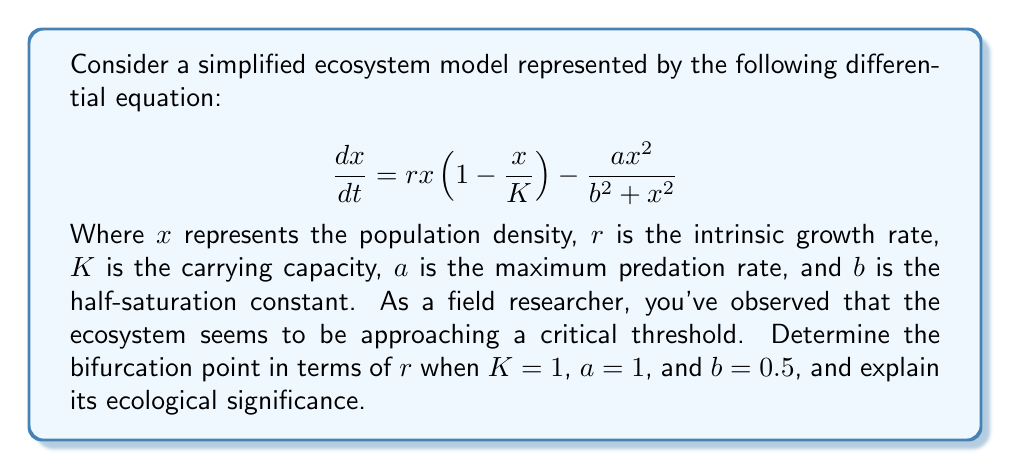Help me with this question. To find the bifurcation point, we need to follow these steps:

1) First, we find the equilibrium points by setting $\frac{dx}{dt} = 0$:

   $$rx(1-x) - \frac{x^2}{0.25 + x^2} = 0$$

2) Factoring out $x$:

   $$x(r(1-x) - \frac{x}{0.25 + x^2}) = 0$$

3) One equilibrium point is $x=0$. For the other(s), we solve:

   $$r(1-x) - \frac{x}{0.25 + x^2} = 0$$

4) Multiply both sides by $(0.25 + x^2)$:

   $$r(1-x)(0.25 + x^2) - x = 0$$

5) Expand:

   $$0.25r - 0.25rx + rx^2 - rx^3 - x = 0$$

6) Rearrange:

   $$-rx^3 + rx^2 - (0.25r + 1)x + 0.25r = 0$$

7) For a bifurcation to occur, this cubic equation should have a double root. This happens when its discriminant is zero. The discriminant of a cubic $ax^3 + bx^2 + cx + d = 0$ is given by:

   $$\Delta = 18abcd - 4b^3d + b^2c^2 - 4ac^3 - 27a^2d^2$$

8) In our case, $a=-r$, $b=r$, $c=-(0.25r+1)$, and $d=0.25r$. Substituting these into the discriminant formula and setting it to zero:

   $$4r^3 + 27r^2 - 27r - 4 = 0$$

9) This equation can be solved numerically to find the bifurcation point. The solution is approximately $r \approx 2.5538$.

Ecological significance: This bifurcation point represents a critical threshold in the ecosystem. Below this value of $r$, the ecosystem has a single stable equilibrium. Above this value, the system exhibits bistability, with two stable equilibria separated by an unstable equilibrium. This indicates that the ecosystem can suddenly shift from one state to another if pushed beyond a tipping point, which is crucial for understanding and managing ecosystem resilience.
Answer: $r \approx 2.5538$ 